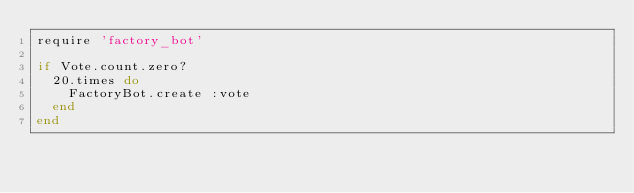Convert code to text. <code><loc_0><loc_0><loc_500><loc_500><_Ruby_>require 'factory_bot'

if Vote.count.zero?
  20.times do
    FactoryBot.create :vote
  end
end
</code> 